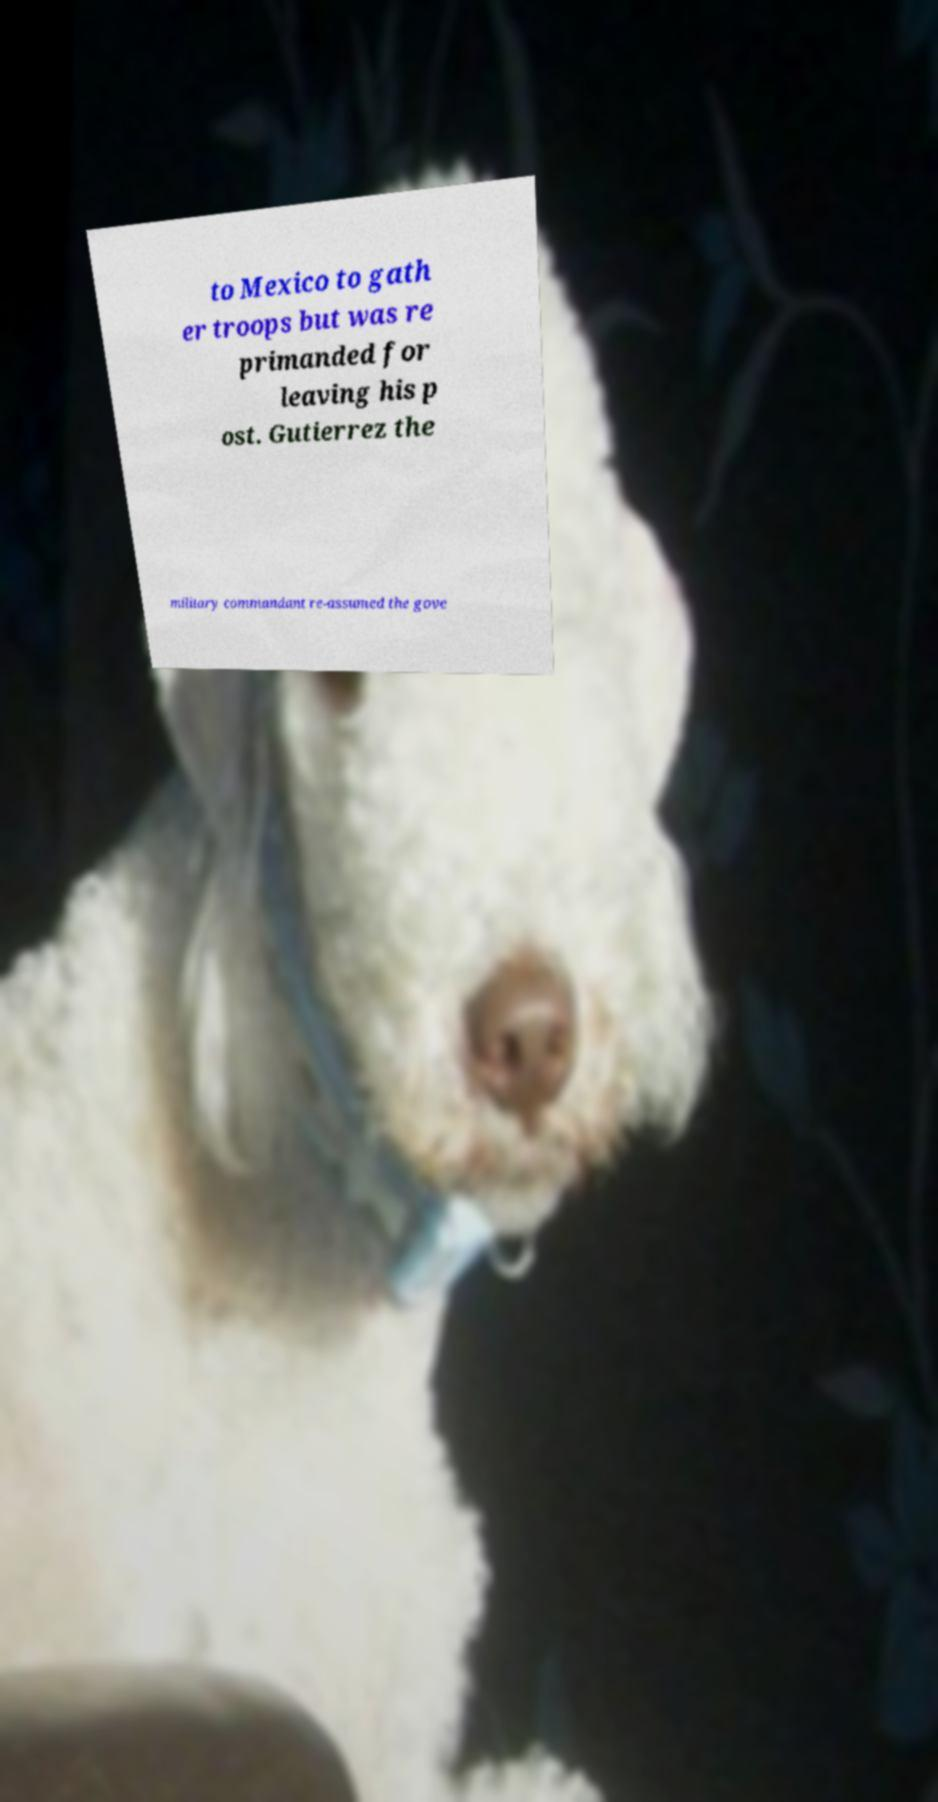Please identify and transcribe the text found in this image. to Mexico to gath er troops but was re primanded for leaving his p ost. Gutierrez the military commandant re-assumed the gove 